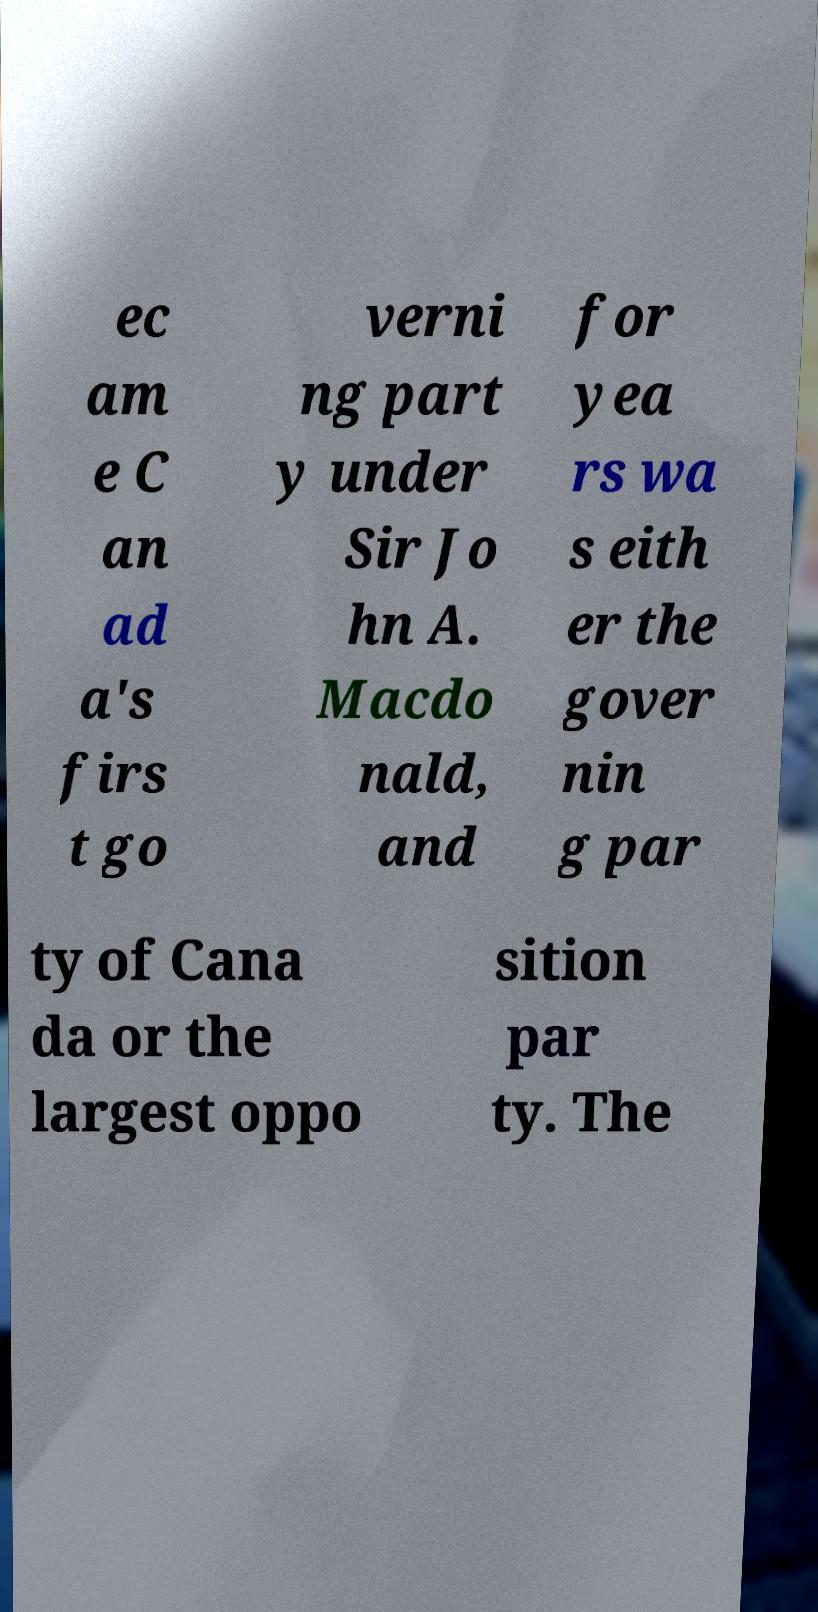What messages or text are displayed in this image? I need them in a readable, typed format. ec am e C an ad a's firs t go verni ng part y under Sir Jo hn A. Macdo nald, and for yea rs wa s eith er the gover nin g par ty of Cana da or the largest oppo sition par ty. The 